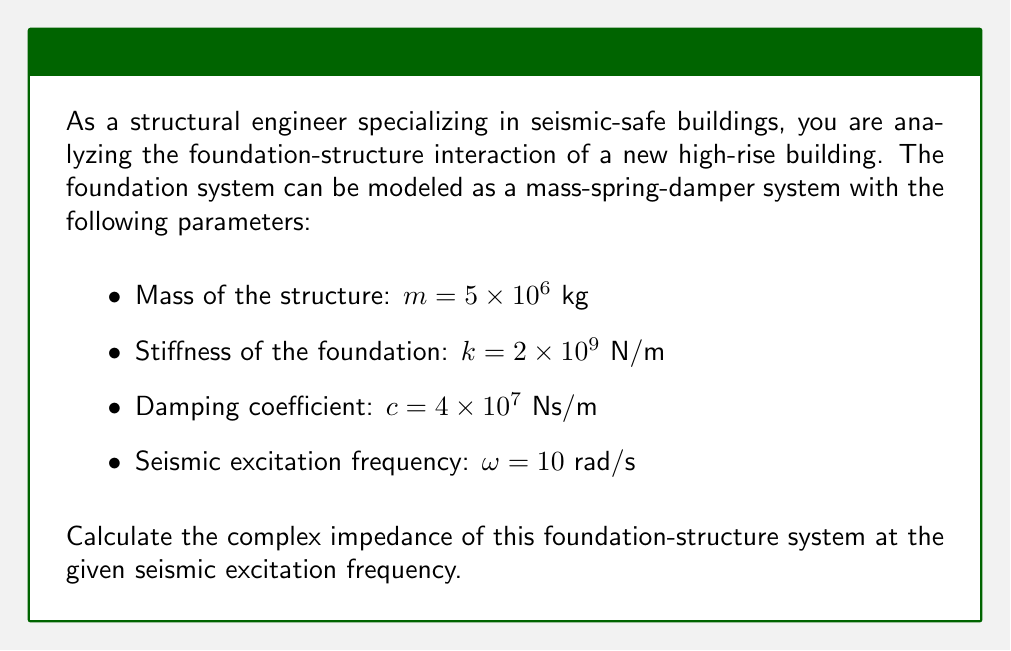Provide a solution to this math problem. To solve this problem, we'll follow these steps:

1) The complex impedance of a mass-spring-damper system is given by the equation:

   $$Z(\omega) = k - \omega^2m + i\omega c$$

   where $i$ is the imaginary unit.

2) We need to substitute the given values into this equation:
   
   $m = 5 \times 10^6$ kg
   $k = 2 \times 10^9$ N/m
   $c = 4 \times 10^7$ Ns/m
   $\omega = 10$ rad/s

3) Let's calculate each term:

   $k = 2 \times 10^9$ N/m

   $-\omega^2m = -(10)^2 \times (5 \times 10^6) = -5 \times 10^8$ N/m

   $i\omega c = i \times 10 \times (4 \times 10^7) = i4 \times 10^8$ Ns/m

4) Now, we can combine these terms:

   $$Z(10) = (2 \times 10^9) + (-5 \times 10^8) + (i4 \times 10^8)$$

5) Simplifying:

   $$Z(10) = 1.5 \times 10^9 + i4 \times 10^8$$

This is the complex impedance of the foundation-structure system at the given seismic excitation frequency.
Answer: $$Z(10) = 1.5 \times 10^9 + i4 \times 10^8$$ N/m 